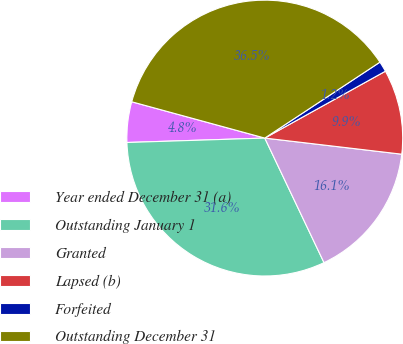<chart> <loc_0><loc_0><loc_500><loc_500><pie_chart><fcel>Year ended December 31 (a)<fcel>Outstanding January 1<fcel>Granted<fcel>Lapsed (b)<fcel>Forfeited<fcel>Outstanding December 31<nl><fcel>4.75%<fcel>31.55%<fcel>16.07%<fcel>9.92%<fcel>1.22%<fcel>36.48%<nl></chart> 